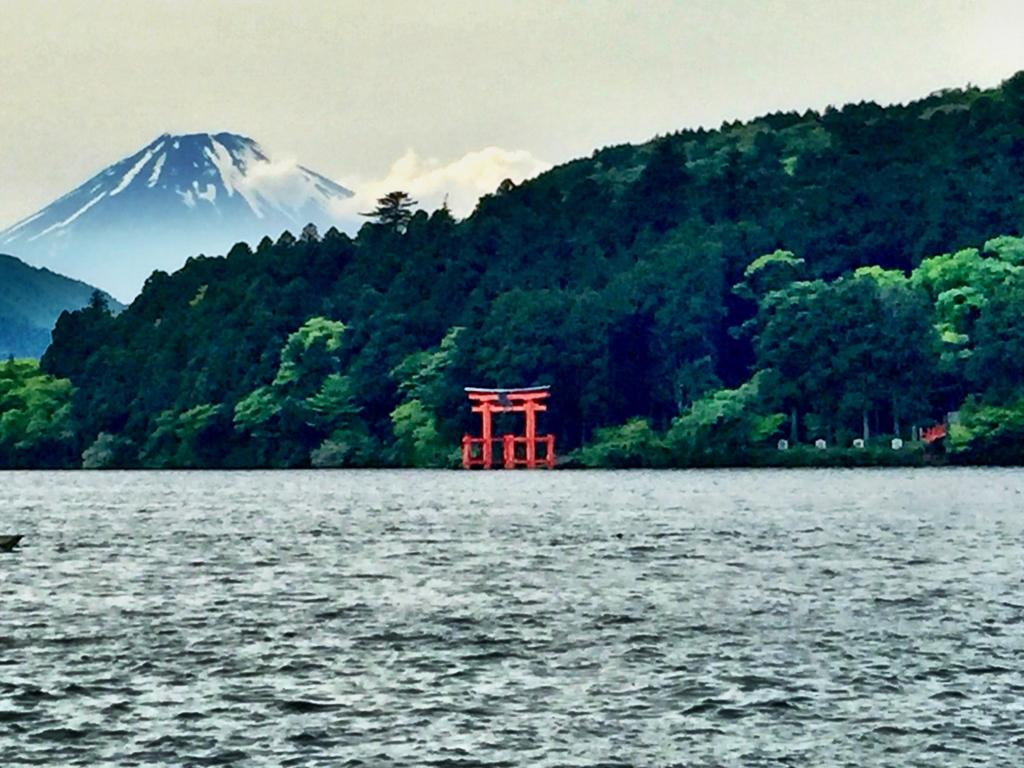What type of vegetation can be seen in the image? There are trees in the image. What is the condition of one of the mountains in the image? There is snow on one of the mountains in the image. What architectural feature is present in the image? There is an arch in the image. What type of structures are present in the image? There are white color pillars in the image. What natural element is visible in the image? There is water visible in the image. What is visible in the sky in the image? The sky is visible in the image. What type of plant is connected to the cord in the image? There is no plant connected to a cord in the image. How does the image end? The image does not have an ending, as it is a static representation. 